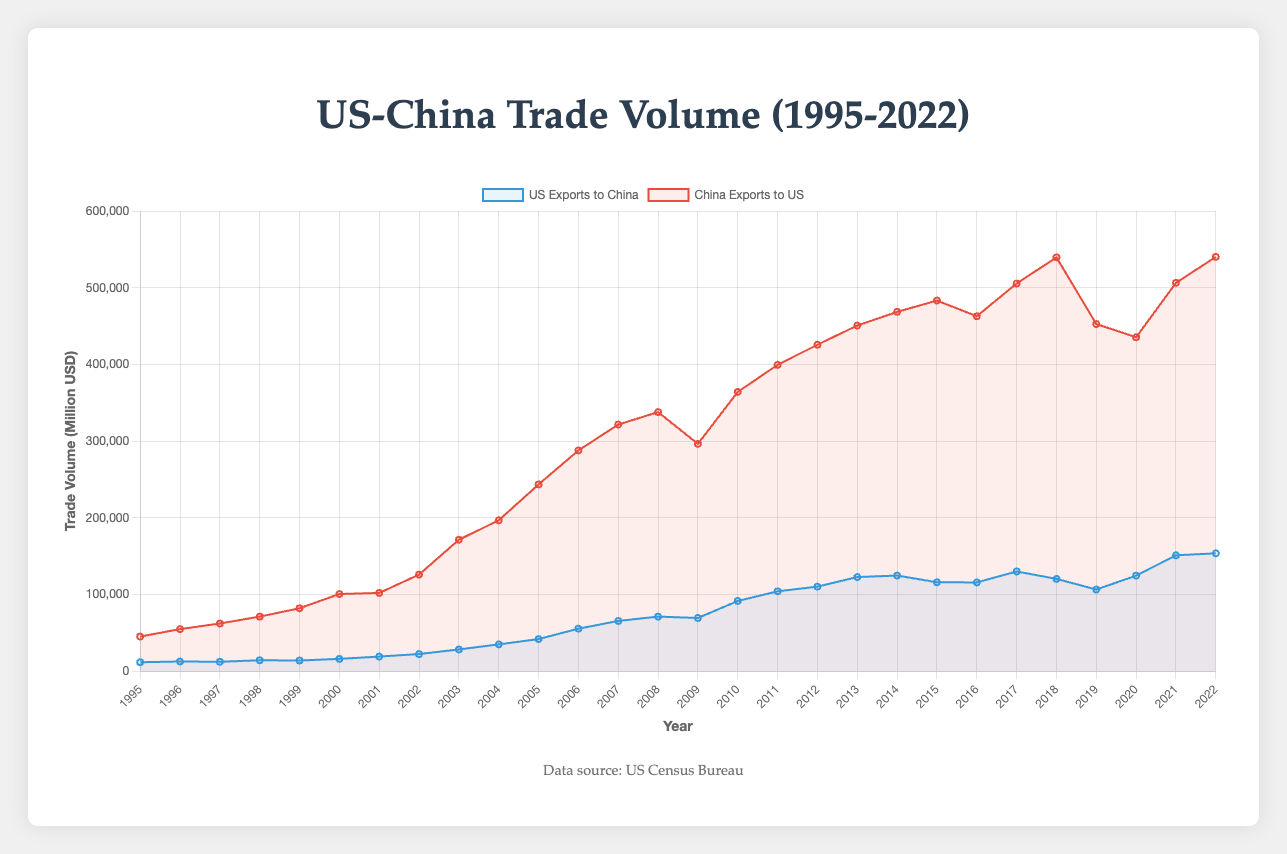What is the highest trade volume recorded for US exports to China? According to the figure, the peak value for US exports to China occurs at the end of the chart. The data point at 2022 indicates the highest recorded value.
Answer: 153,630 million USD When did China exports to the US first exceed 500,000 million USD? Looking at the red line representing China’s exports to the US, we notice it first crosses the 500,000 million USD mark around the year 2017.
Answer: 2017 Compare the trade volumes between US exports to China and China exports to the US in 2010. Which was greater and by how much? In 2010, US exports to China were 91,500 million USD, and China exports to the US were 364,100 million USD. Subtracting these values gives 364,100 - 91,500.
Answer: China exports by 272,600 million USD Identify the trend in US exports to China from 2000 to 2022. Observing the blue line from 2000 to 2022 shows an overall increasing trend, despite some fluctuations around the year 2015-2020.
Answer: Increasing trend In which year did US exports to China experience the most significant drop? By inspecting the blue line, it is evident that the most significant drop occurs around 2008-2009. US exports to China drop from 71,100 million USD in 2008 to 69,350 million USD in 2009.
Answer: 2009 What was the total trade volume between the US and China in 2015? In 2015, US exports to China were 115,910 million USD, and China exports to the US were 483,200 million USD. Adding these gives 115,910 + 483,200.
Answer: 599,110 million USD What is the overall trend of China’s exports to the US from 1995 to 2022? The red line representing China’s exports to the US consistently increases from 1995 to 2022, indicating a long-term upward trend.
Answer: Upward trend Calculate the average annual export volume from the US to China over the period 1995-2022. Sum all the annual export volumes from the US to China from 1995 to 2022 and then divide by the number of years (28). (11600+12600+12200+...+153630)/28.
Answer: 68,940.36 million USD How did the trade volumes between China and the US change from 2019 to 2020? From the year 2019 to 2020, US exports to China went from 106,440 million USD to 124,560 million USD (an increase), whereas China exports to the US decreased from 452,550 million USD to 435,370 million USD.
Answer: US exports increased, China exports decreased Compare the trade volumes in the years just before and after the 2008 financial crisis. What can you deduce? In 2007, US exports to China were 65,450 million USD and increased to 71,100 million USD in 2008. In 2009, they dropped to 69,350 million USD. China's exports to the US were 321,540 million USD in 2007, increased to 337,770 million USD in 2008, and then decreased to 296,370 million USD in 2009.
Answer: US exports increased then dropped; China exports increased then dropped significantly 